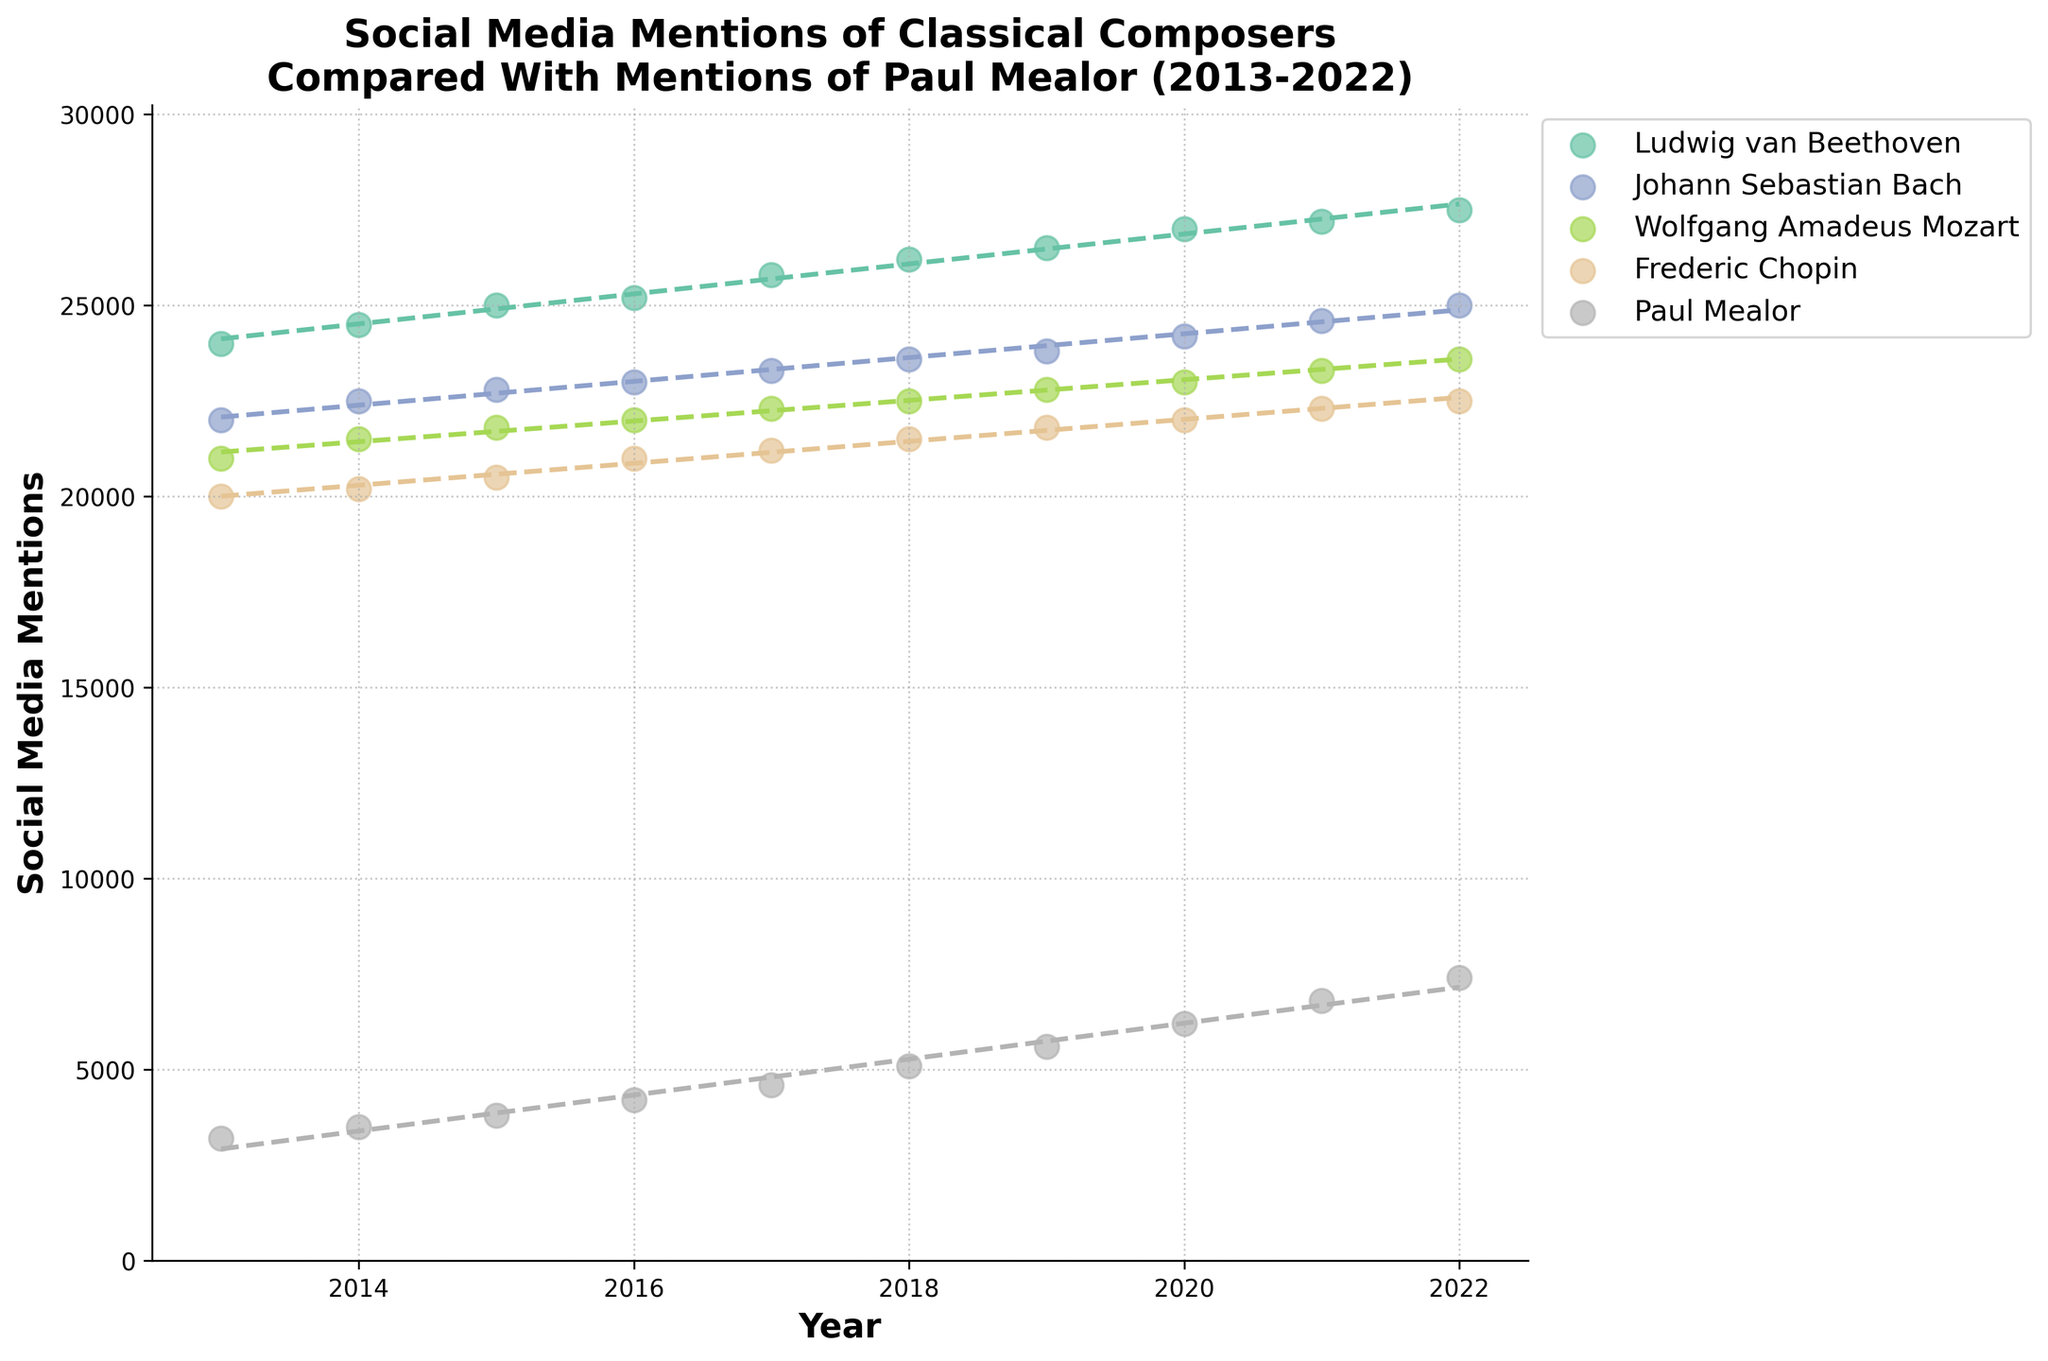What's the title of the figure? The title is located at the top of the figure, indicating what the figure is about.
Answer: Social Media Mentions of Classical Composers Compared With Mentions of Paul Mealor (2013-2022) What is the color scheme used to distinguish different composers in the plot? Different colors are used to represent each composer, visible in both the scatter points and the trend lines. These colors are displayed in the legend on the right side of the plot.
Answer: Different colors Which composer has the highest number of social media mentions in 2022? By looking at the scatter plot for the year 2022, identify which composer's data point is the highest along the y-axis.
Answer: Ludwig van Beethoven What is the trend in social media mentions for Paul Mealor over the years? This can be identified by observing the scatter points and the trend line for Paul Mealor, which generally increase over the years. This suggests a gradual rise in mentions.
Answer: Increasing trend How do the social media mentions of Frederick Chopin in 2021 compare with those in 2022? Locate Frederick Chopin's data points for 2021 and 2022 and compare the y-values.
Answer: 22300 in 2021 and 22500 in 2022 Calculate the average number of social media mentions for Wolfgang Amadeus Mozart from 2013 to 2022. Find the mentions for each year from 2013 to 2022 for Wolfgang Amadeus Mozart, sum them up and divide by the number of years (10).
Answer: 22,300 Between Johann Sebastian Bach and Paul Mealor, who experienced a steeper rise in mentions over the decade? By comparing the slopes of the trend lines for Johann Sebastian Bach and Paul Mealor, we see which trend line has a greater incline.
Answer: Paul Mealor Which year showed the greatest increase in social media mentions for Paul Mealor? Observe the change between consecutive scatter points for Paul Mealor and identify the year with the biggest jump on the y-axis.
Answer: 2020-2021 Compare the range of social media mentions for Ludwig van Beethoven and Paul Mealor from 2013 to 2022. Find the difference between the maximum and minimum mentions for both composers over the decade.
Answer: Larger for Beethoven Is there a year where the social media mentions for Paul Mealor surpass those of Frederic Chopin? Compare the scatter plot points of Paul Mealor and Frederic Chopin year by year to see if Paul Mealor's mentions ever exceed those of Frederic Chopin.
Answer: No 